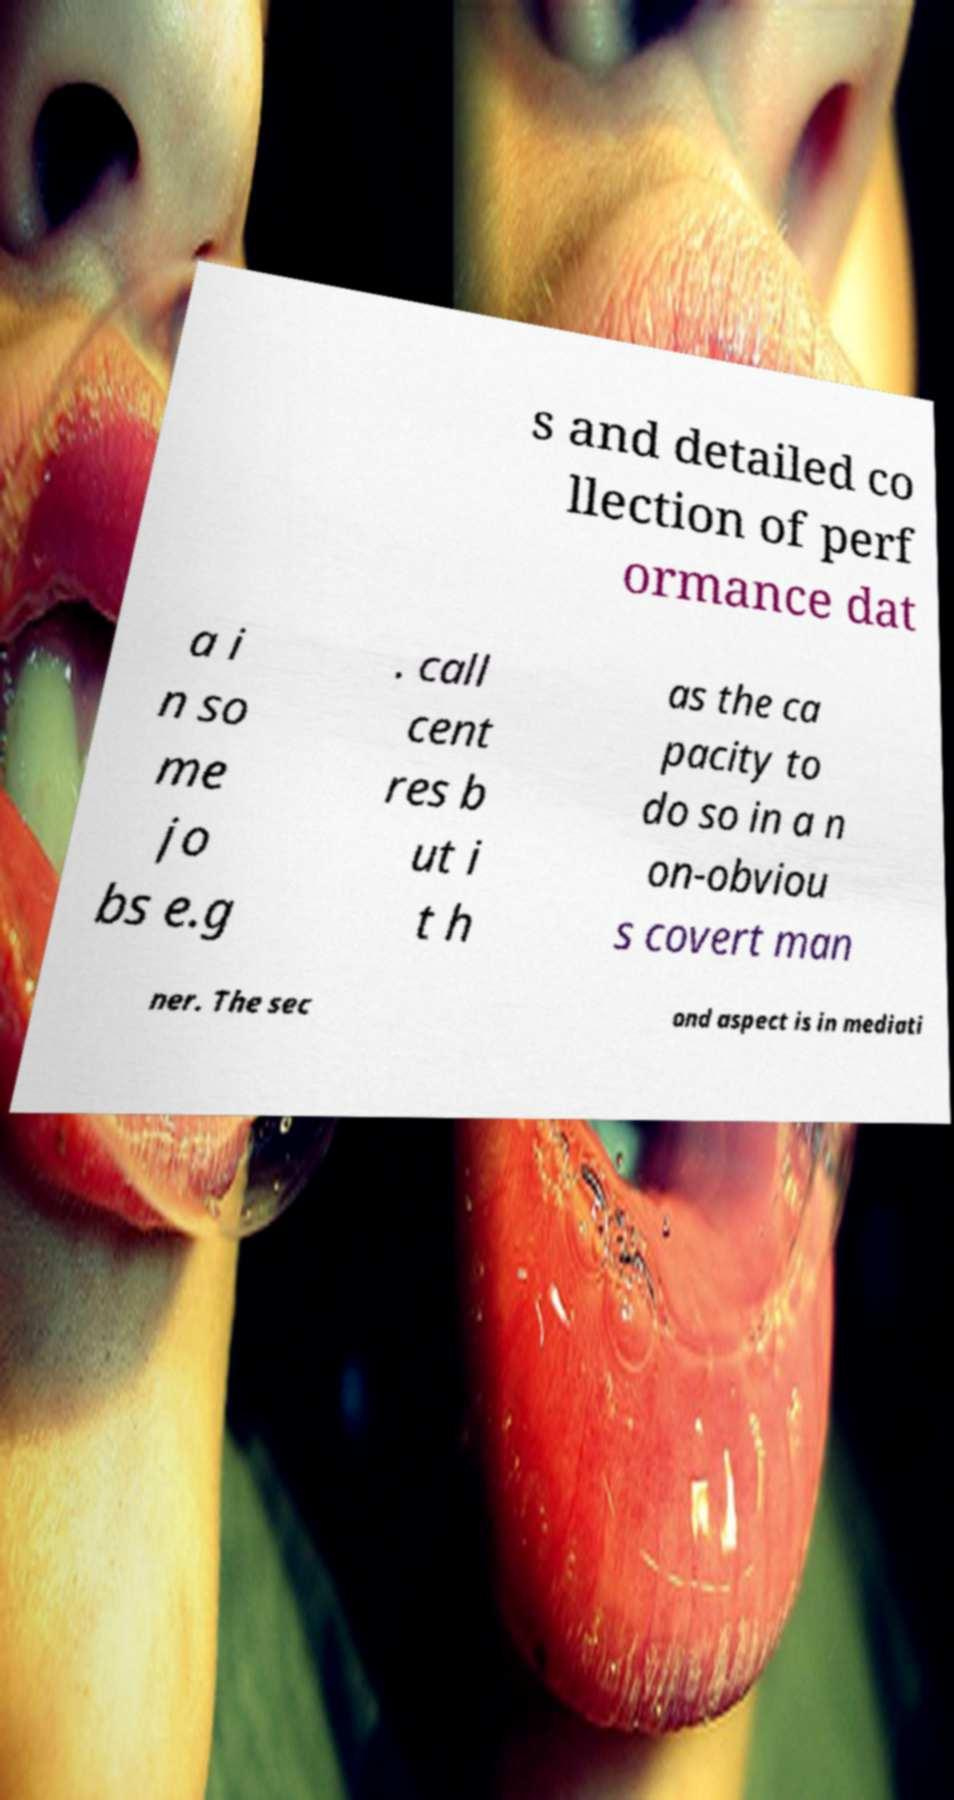Can you accurately transcribe the text from the provided image for me? s and detailed co llection of perf ormance dat a i n so me jo bs e.g . call cent res b ut i t h as the ca pacity to do so in a n on-obviou s covert man ner. The sec ond aspect is in mediati 